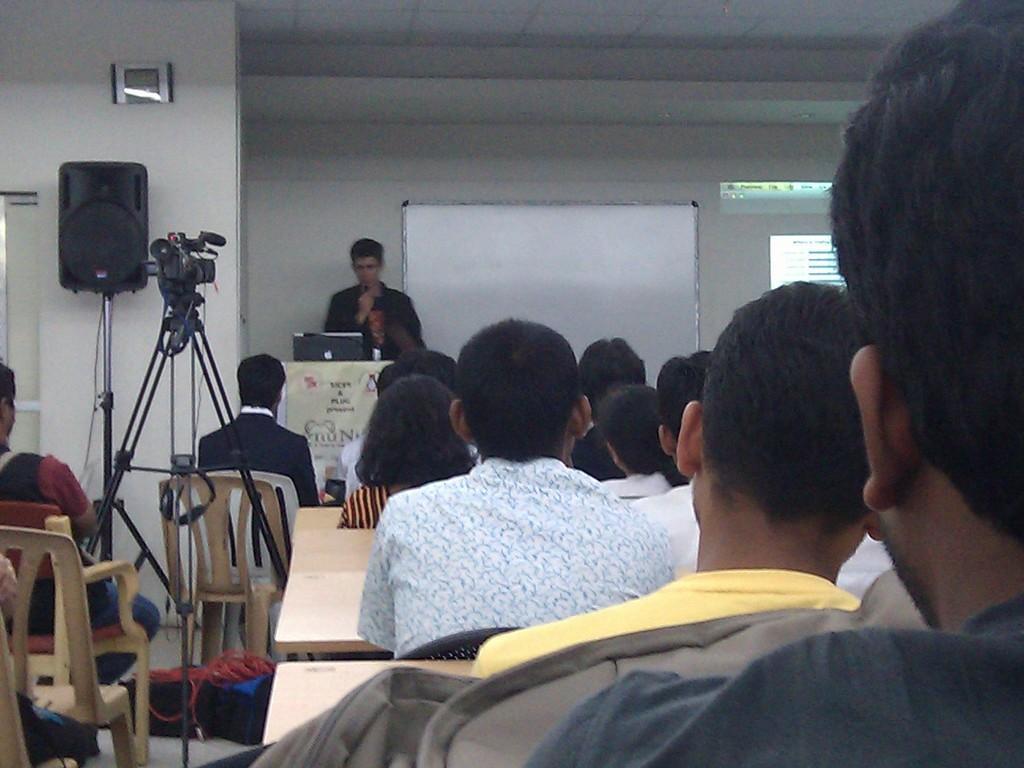In one or two sentences, can you explain what this image depicts? In this image On the right there are many people sitting on the chairs and staring at the person. On the left there is camera, speaker and chairs. In the middle there is a man he is speaking something and staring at laptop. In the background there is whiteboard, screen, wall and clock. 